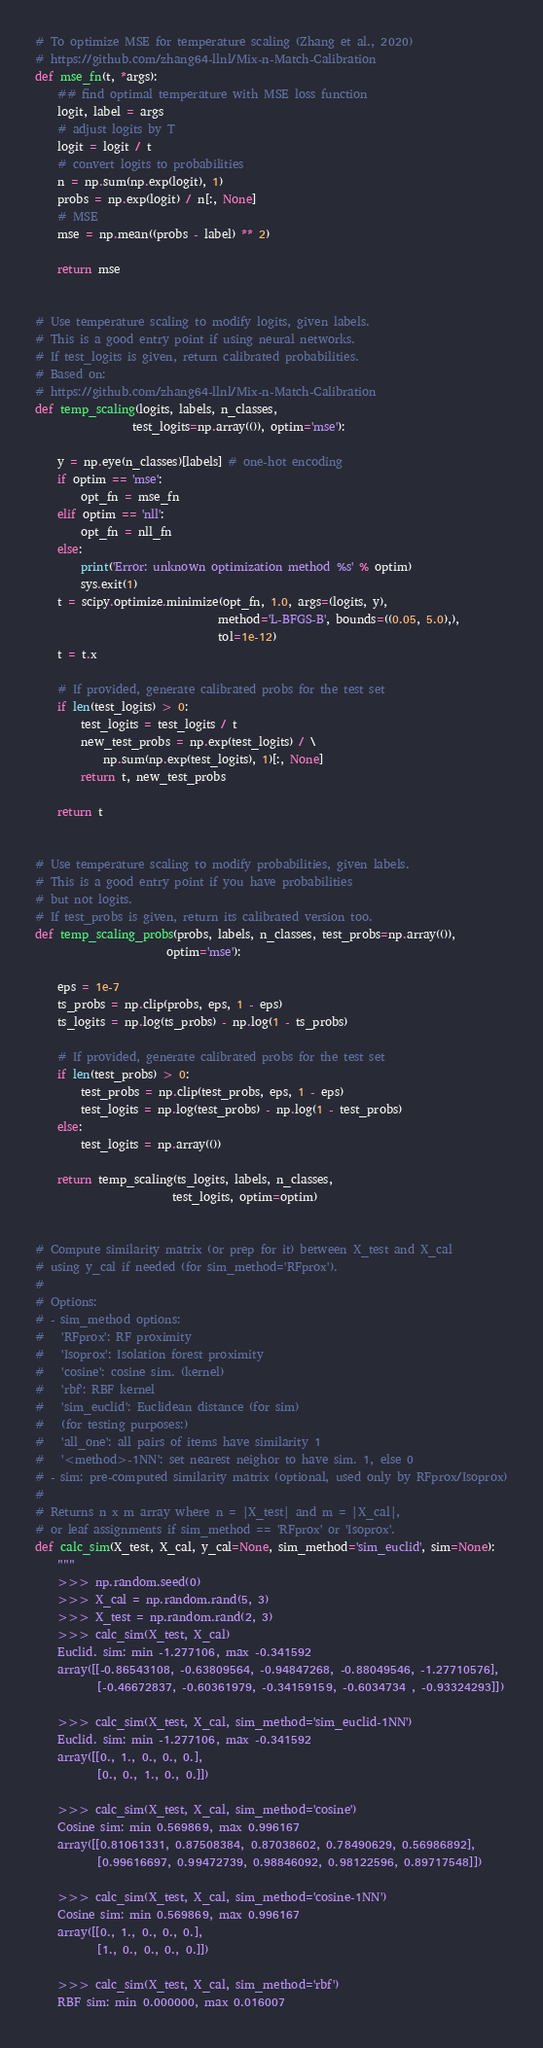<code> <loc_0><loc_0><loc_500><loc_500><_Python_>
# To optimize MSE for temperature scaling (Zhang et al., 2020)
# https://github.com/zhang64-llnl/Mix-n-Match-Calibration
def mse_fn(t, *args):
    ## find optimal temperature with MSE loss function
    logit, label = args
    # adjust logits by T
    logit = logit / t
    # convert logits to probabilities
    n = np.sum(np.exp(logit), 1)
    probs = np.exp(logit) / n[:, None]
    # MSE
    mse = np.mean((probs - label) ** 2)

    return mse


# Use temperature scaling to modify logits, given labels.
# This is a good entry point if using neural networks.
# If test_logits is given, return calibrated probabilities.
# Based on:
# https://github.com/zhang64-llnl/Mix-n-Match-Calibration
def temp_scaling(logits, labels, n_classes,
                 test_logits=np.array(()), optim='mse'):

    y = np.eye(n_classes)[labels] # one-hot encoding
    if optim == 'mse':
        opt_fn = mse_fn
    elif optim == 'nll':
        opt_fn = nll_fn
    else:
        print('Error: unknown optimization method %s' % optim)
        sys.exit(1)
    t = scipy.optimize.minimize(opt_fn, 1.0, args=(logits, y),
                                method='L-BFGS-B', bounds=((0.05, 5.0),),
                                tol=1e-12)
    t = t.x

    # If provided, generate calibrated probs for the test set
    if len(test_logits) > 0:
        test_logits = test_logits / t
        new_test_probs = np.exp(test_logits) / \
            np.sum(np.exp(test_logits), 1)[:, None]
        return t, new_test_probs

    return t


# Use temperature scaling to modify probabilities, given labels.
# This is a good entry point if you have probabilities
# but not logits.
# If test_probs is given, return its calibrated version too.
def temp_scaling_probs(probs, labels, n_classes, test_probs=np.array(()),
                       optim='mse'):

    eps = 1e-7
    ts_probs = np.clip(probs, eps, 1 - eps)
    ts_logits = np.log(ts_probs) - np.log(1 - ts_probs)

    # If provided, generate calibrated probs for the test set
    if len(test_probs) > 0:
        test_probs = np.clip(test_probs, eps, 1 - eps)
        test_logits = np.log(test_probs) - np.log(1 - test_probs)
    else:
        test_logits = np.array(())

    return temp_scaling(ts_logits, labels, n_classes,
                        test_logits, optim=optim)


# Compute similarity matrix (or prep for it) between X_test and X_cal
# using y_cal if needed (for sim_method='RFprox').
#
# Options:
# - sim_method options:
#   'RFprox': RF proximity
#   'Isoprox': Isolation forest proximity
#   'cosine': cosine sim. (kernel)
#   'rbf': RBF kernel
#   'sim_euclid': Euclidean distance (for sim)
#   (for testing purposes:)
#   'all_one': all pairs of items have similarity 1
#   '<method>-1NN': set nearest neighor to have sim. 1, else 0
# - sim: pre-computed similarity matrix (optional, used only by RFprox/Isoprox)
#
# Returns n x m array where n = |X_test| and m = |X_cal|,
# or leaf assignments if sim_method == 'RFprox' or 'Isoprox'.
def calc_sim(X_test, X_cal, y_cal=None, sim_method='sim_euclid', sim=None):
    """
    >>> np.random.seed(0)
    >>> X_cal = np.random.rand(5, 3)
    >>> X_test = np.random.rand(2, 3)
    >>> calc_sim(X_test, X_cal)
    Euclid. sim: min -1.277106, max -0.341592
    array([[-0.86543108, -0.63809564, -0.94847268, -0.88049546, -1.27710576],
           [-0.46672837, -0.60361979, -0.34159159, -0.6034734 , -0.93324293]])

    >>> calc_sim(X_test, X_cal, sim_method='sim_euclid-1NN')
    Euclid. sim: min -1.277106, max -0.341592
    array([[0., 1., 0., 0., 0.],
           [0., 0., 1., 0., 0.]])

    >>> calc_sim(X_test, X_cal, sim_method='cosine')
    Cosine sim: min 0.569869, max 0.996167
    array([[0.81061331, 0.87508384, 0.87038602, 0.78490629, 0.56986892],
           [0.99616697, 0.99472739, 0.98846092, 0.98122596, 0.89717548]])

    >>> calc_sim(X_test, X_cal, sim_method='cosine-1NN')
    Cosine sim: min 0.569869, max 0.996167
    array([[0., 1., 0., 0., 0.],
           [1., 0., 0., 0., 0.]])

    >>> calc_sim(X_test, X_cal, sim_method='rbf')
    RBF sim: min 0.000000, max 0.016007</code> 